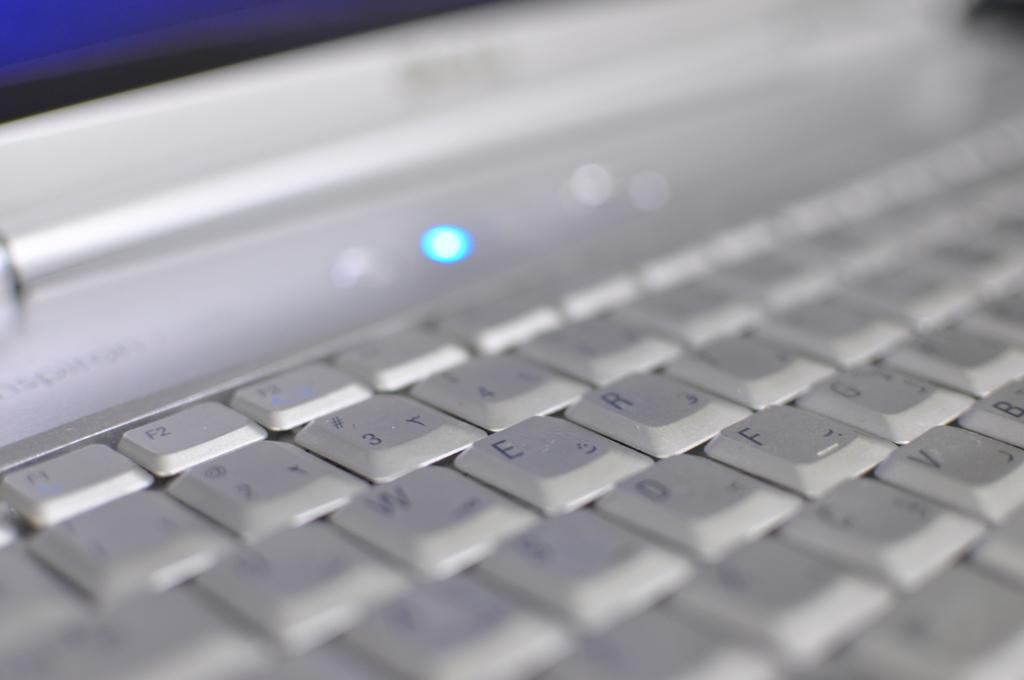<image>
Create a compact narrative representing the image presented. A laptop keyboard is displayed, the number 3 and the letter F are visible. 